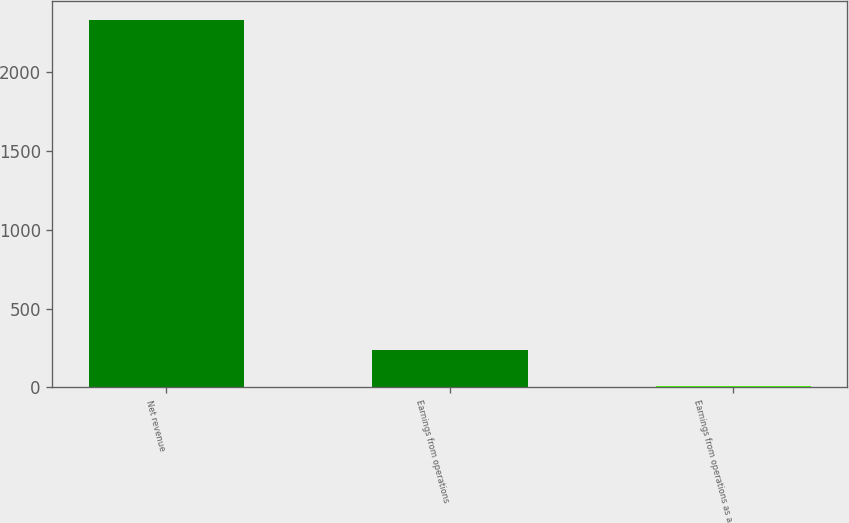<chart> <loc_0><loc_0><loc_500><loc_500><bar_chart><fcel>Net revenue<fcel>Earnings from operations<fcel>Earnings from operations as a<nl><fcel>2336<fcel>239.54<fcel>6.6<nl></chart> 